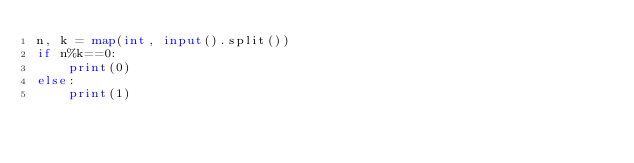Convert code to text. <code><loc_0><loc_0><loc_500><loc_500><_Python_>n, k = map(int, input().split())
if n%k==0:
    print(0)
else:
    print(1)</code> 